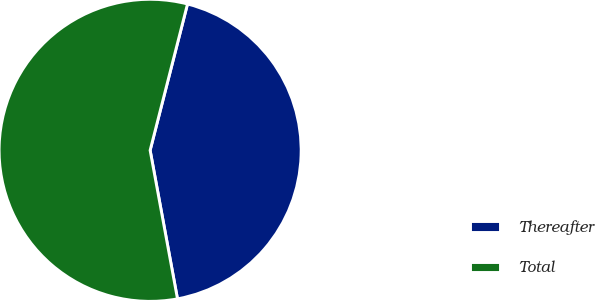Convert chart to OTSL. <chart><loc_0><loc_0><loc_500><loc_500><pie_chart><fcel>Thereafter<fcel>Total<nl><fcel>43.12%<fcel>56.88%<nl></chart> 